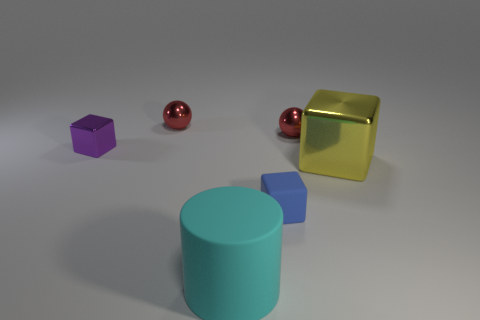Add 2 tiny blue cubes. How many objects exist? 8 Subtract all small shiny cubes. How many cubes are left? 2 Subtract all cylinders. How many objects are left? 5 Subtract 2 cubes. How many cubes are left? 1 Add 2 small brown metallic balls. How many small brown metallic balls exist? 2 Subtract 0 brown cylinders. How many objects are left? 6 Subtract all purple cubes. Subtract all yellow cylinders. How many cubes are left? 2 Subtract all red balls. How many purple blocks are left? 1 Subtract all rubber things. Subtract all red metallic spheres. How many objects are left? 2 Add 4 rubber cubes. How many rubber cubes are left? 5 